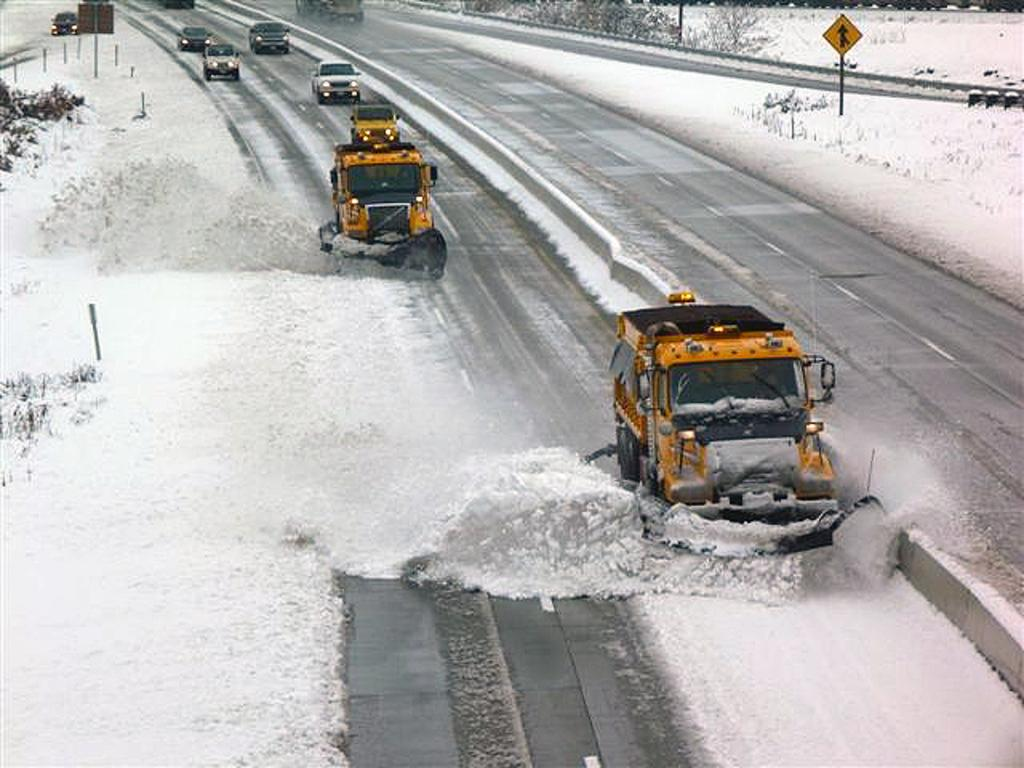What can be seen on the road in the image? There are vehicles on the road in the image. What type of natural elements are visible in the image? There are trees visible in the image. What structures can be seen in the image? There are poles in the image. What body of water is visible in the image? There is water visible in the image. What type of signage or information is present in the image? There are boards in the image. Can you tell me how many sticks are floating in the lake in the image? There is no lake present in the image, and therefore no sticks floating in it. What form does the water take in the image? The water is visible in the image, but its form is not specified. 